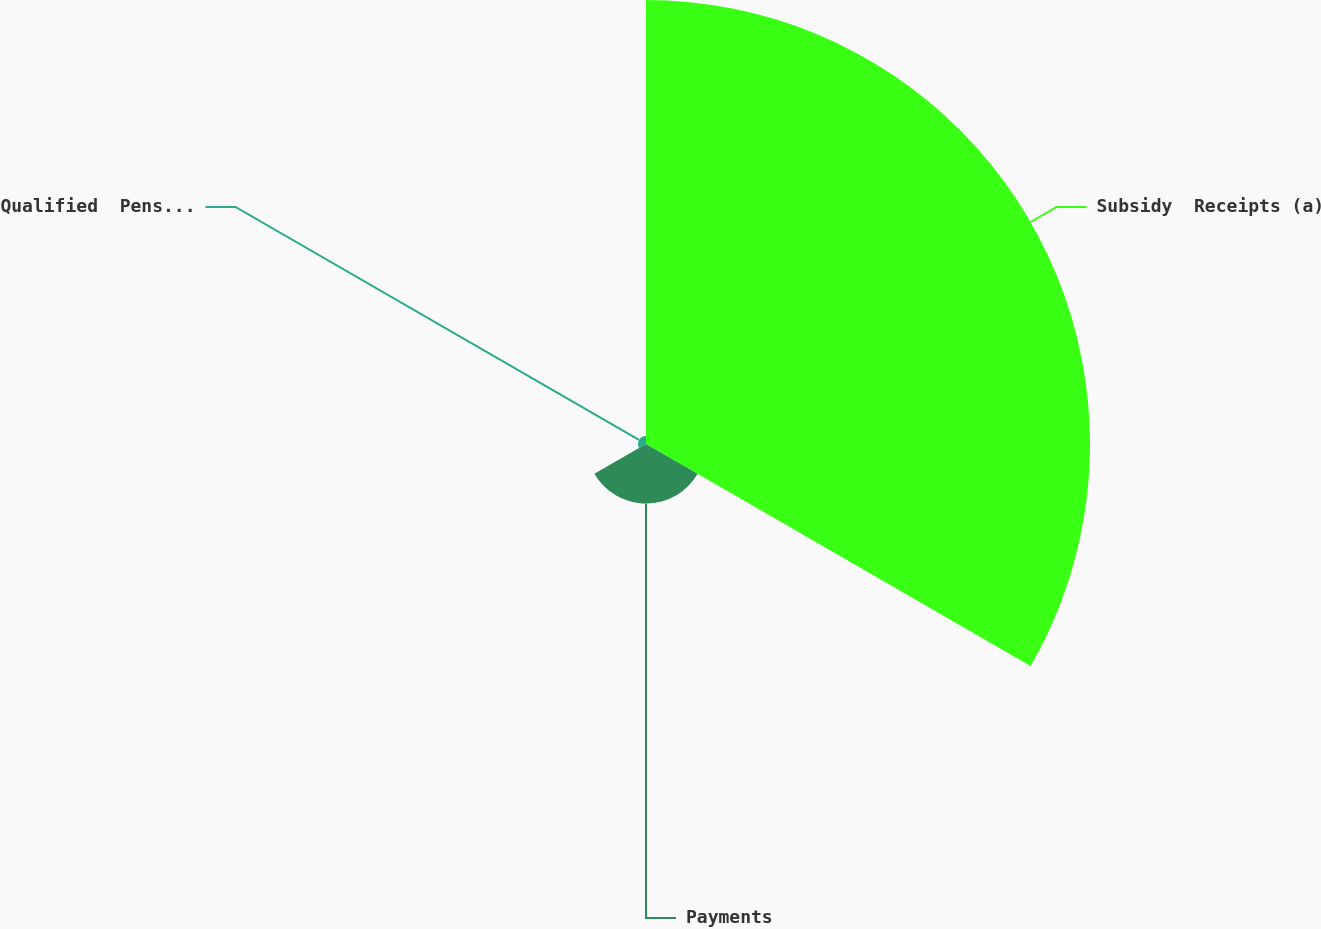<chart> <loc_0><loc_0><loc_500><loc_500><pie_chart><fcel>Subsidy  Receipts (a)<fcel>Payments<fcel>Qualified  Pension Benefits<nl><fcel>86.78%<fcel>11.65%<fcel>1.58%<nl></chart> 